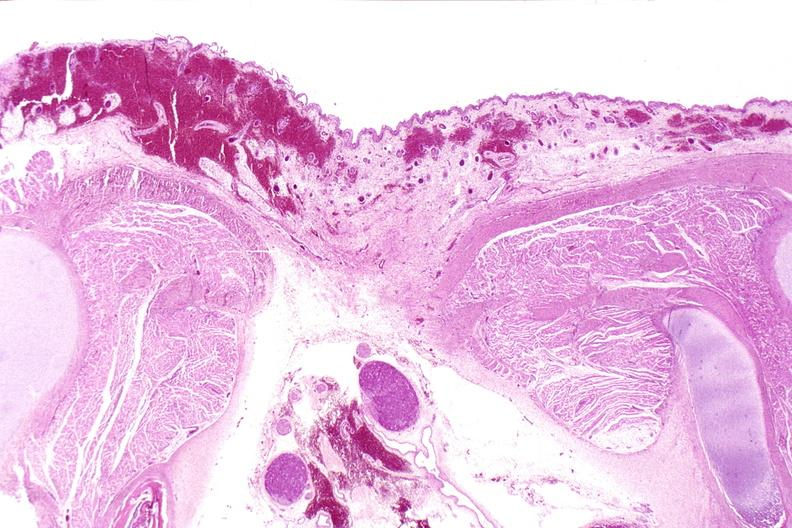does this image show neural tube defect, meningomyelocele?
Answer the question using a single word or phrase. Yes 